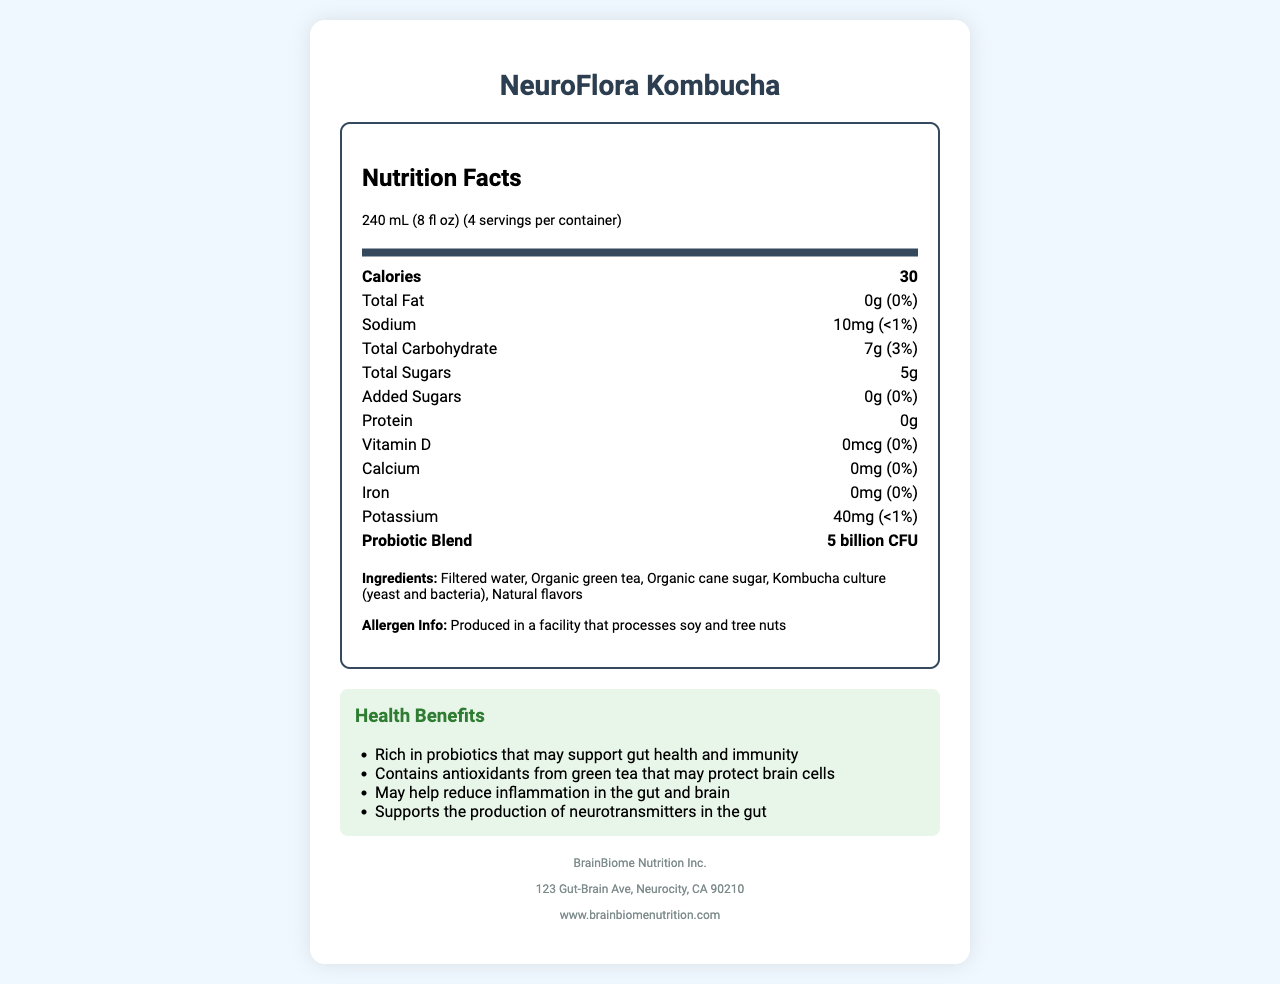What is the serving size of NeuroFlora Kombucha? The document specifies that the serving size of NeuroFlora Kombucha is 240 mL (8 fl oz).
Answer: 240 mL (8 fl oz) How many calories are there per serving of NeuroFlora Kombucha? The Nutrition Facts section of the document lists the calories per serving as 30.
Answer: 30 Name the types of probiotics included in NeuroFlora Kombucha. The probiotic strains are listed under the Probiotic Blend section in the document.
Answer: Lactobacillus plantarum, Lactobacillus brevis, Bifidobacterium longum What is the total carbohydrate content in one serving? The Nutrition Facts section shows that one serving contains 7 grams of total carbohydrates, which is 3% of the daily value.
Answer: 7g (3% DV) Which company manufactures NeuroFlora Kombucha? The Manufacturer Info section at the end of the document states that the manufacturer is BrainBiome Nutrition Inc.
Answer: BrainBiome Nutrition Inc. Which key nutrient supporting brain health is missing in NeuroFlora Kombucha? A. Omega-3 Fatty Acids B. Vitamin D C. Folate According to the Nutrition Facts, Vitamin D is listed as 0mcg (0% DV), indicating that it is absent in the product.
Answer: B. Vitamin D How much protein does one serving of NeuroFlora Kombucha contain? The Nutrition Facts section specifies that each serving contains 0 grams of protein.
Answer: 0g Is NeuroFlora Kombucha high in sodium? Yes/No The document lists the sodium content as 10mg (<1% DV), indicating it is low in sodium.
Answer: No Which health benefit is not claimed by NeuroFlora Kombucha? A. Supports gut-brain axis B. May boost energy levels C. May promote cognitive function The health benefits mentioned include supporting the gut-brain axis and promoting cognitive function, but it does not claim to boost energy levels.
Answer: B. May boost energy levels Summarize the main idea of the NeuroFlora Kombucha nutrition facts label. The document provides detailed nutritional information, highlighting its low calorie and nutrient content, the presence of beneficial probiotic strains, and its various health benefits related to gut and brain health, including support for cognitive function and neurotransmitter production.
Answer: NeuroFlora Kombucha is a low-calorie, probiotic-rich fermented beverage that supports gut-brain health through live cultures, green tea antioxidants, and inflammation-reducing properties. How many servings are there per container of NeuroFlora Kombucha? The serving information section states that there are 4 servings per container.
Answer: 4 What special claims does the product make about its health benefits? These special claims are explicitly mentioned under the Special Claims section.
Answer: Contains live cultures, Supports gut-brain axis, May promote cognitive function, Naturally fermented What is the allergen information for NeuroFlora Kombucha? The allergen information is provided in the ingredient list section of the document.
Answer: Produced in a facility that processes soy and tree nuts What additional sugar content does NeuroFlora Kombucha have? The document states that the added sugars are 0g, which is 0% of the daily value.
Answer: 0g (0% DV) Where can consumers go for more information about the product? The Manufacturer Info section lists the website www.brainbiomenutrition.com for more information.
Answer: www.brainbiomenutrition.com How well does NeuroFlora Kombucha address iron intake? The Nutrition Facts indicate that the product contains no iron, listed as 0mg and 0% DV.
Answer: 0mg (0% DV) What additional probiotic strains could be included in future formulations to support brain health? The document does not provide information on which additional probiotic strains could be included to support brain health.
Answer: Cannot be determined 